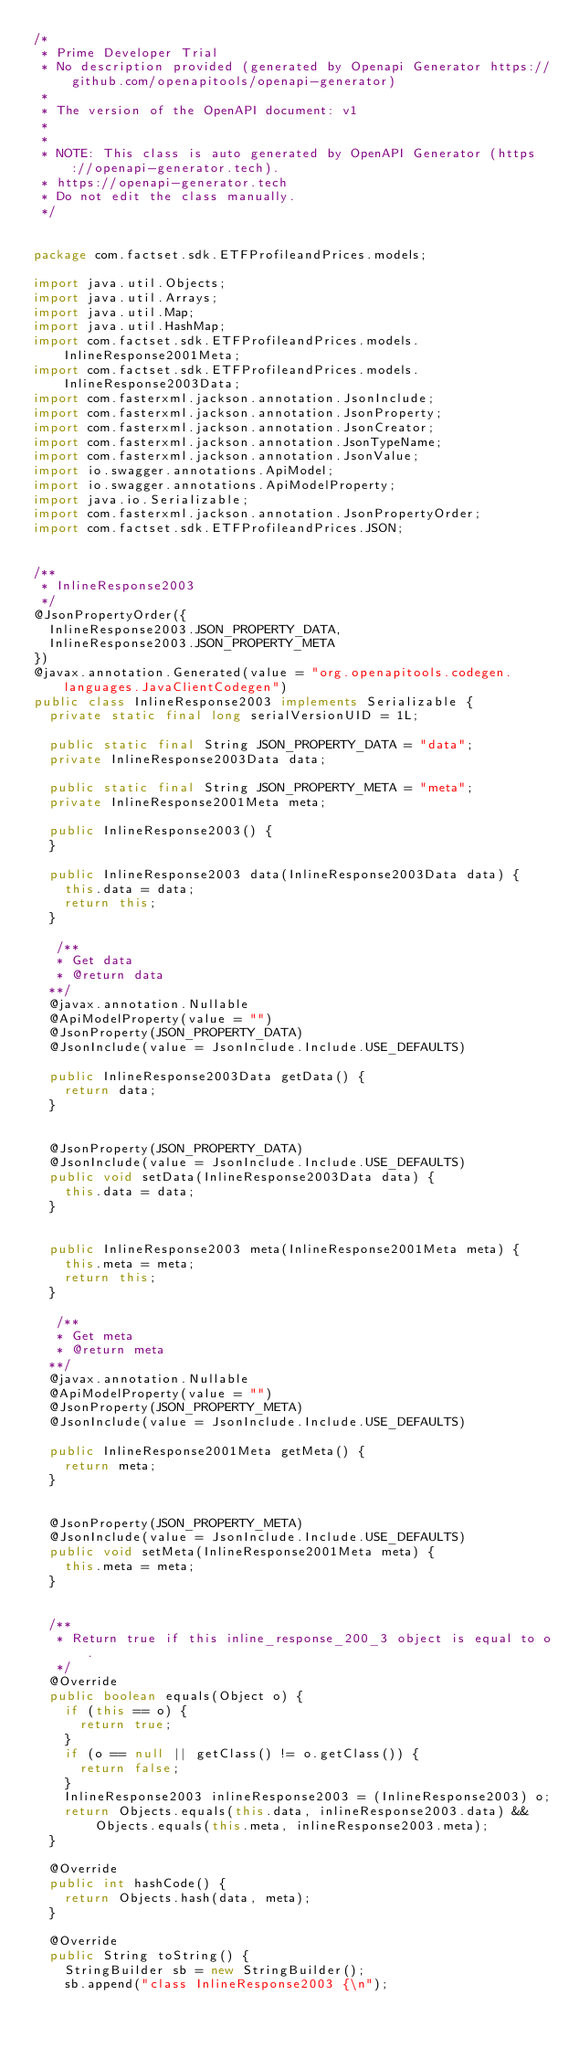Convert code to text. <code><loc_0><loc_0><loc_500><loc_500><_Java_>/*
 * Prime Developer Trial
 * No description provided (generated by Openapi Generator https://github.com/openapitools/openapi-generator)
 *
 * The version of the OpenAPI document: v1
 * 
 *
 * NOTE: This class is auto generated by OpenAPI Generator (https://openapi-generator.tech).
 * https://openapi-generator.tech
 * Do not edit the class manually.
 */


package com.factset.sdk.ETFProfileandPrices.models;

import java.util.Objects;
import java.util.Arrays;
import java.util.Map;
import java.util.HashMap;
import com.factset.sdk.ETFProfileandPrices.models.InlineResponse2001Meta;
import com.factset.sdk.ETFProfileandPrices.models.InlineResponse2003Data;
import com.fasterxml.jackson.annotation.JsonInclude;
import com.fasterxml.jackson.annotation.JsonProperty;
import com.fasterxml.jackson.annotation.JsonCreator;
import com.fasterxml.jackson.annotation.JsonTypeName;
import com.fasterxml.jackson.annotation.JsonValue;
import io.swagger.annotations.ApiModel;
import io.swagger.annotations.ApiModelProperty;
import java.io.Serializable;
import com.fasterxml.jackson.annotation.JsonPropertyOrder;
import com.factset.sdk.ETFProfileandPrices.JSON;


/**
 * InlineResponse2003
 */
@JsonPropertyOrder({
  InlineResponse2003.JSON_PROPERTY_DATA,
  InlineResponse2003.JSON_PROPERTY_META
})
@javax.annotation.Generated(value = "org.openapitools.codegen.languages.JavaClientCodegen")
public class InlineResponse2003 implements Serializable {
  private static final long serialVersionUID = 1L;

  public static final String JSON_PROPERTY_DATA = "data";
  private InlineResponse2003Data data;

  public static final String JSON_PROPERTY_META = "meta";
  private InlineResponse2001Meta meta;

  public InlineResponse2003() { 
  }

  public InlineResponse2003 data(InlineResponse2003Data data) {
    this.data = data;
    return this;
  }

   /**
   * Get data
   * @return data
  **/
  @javax.annotation.Nullable
  @ApiModelProperty(value = "")
  @JsonProperty(JSON_PROPERTY_DATA)
  @JsonInclude(value = JsonInclude.Include.USE_DEFAULTS)

  public InlineResponse2003Data getData() {
    return data;
  }


  @JsonProperty(JSON_PROPERTY_DATA)
  @JsonInclude(value = JsonInclude.Include.USE_DEFAULTS)
  public void setData(InlineResponse2003Data data) {
    this.data = data;
  }


  public InlineResponse2003 meta(InlineResponse2001Meta meta) {
    this.meta = meta;
    return this;
  }

   /**
   * Get meta
   * @return meta
  **/
  @javax.annotation.Nullable
  @ApiModelProperty(value = "")
  @JsonProperty(JSON_PROPERTY_META)
  @JsonInclude(value = JsonInclude.Include.USE_DEFAULTS)

  public InlineResponse2001Meta getMeta() {
    return meta;
  }


  @JsonProperty(JSON_PROPERTY_META)
  @JsonInclude(value = JsonInclude.Include.USE_DEFAULTS)
  public void setMeta(InlineResponse2001Meta meta) {
    this.meta = meta;
  }


  /**
   * Return true if this inline_response_200_3 object is equal to o.
   */
  @Override
  public boolean equals(Object o) {
    if (this == o) {
      return true;
    }
    if (o == null || getClass() != o.getClass()) {
      return false;
    }
    InlineResponse2003 inlineResponse2003 = (InlineResponse2003) o;
    return Objects.equals(this.data, inlineResponse2003.data) &&
        Objects.equals(this.meta, inlineResponse2003.meta);
  }

  @Override
  public int hashCode() {
    return Objects.hash(data, meta);
  }

  @Override
  public String toString() {
    StringBuilder sb = new StringBuilder();
    sb.append("class InlineResponse2003 {\n");</code> 